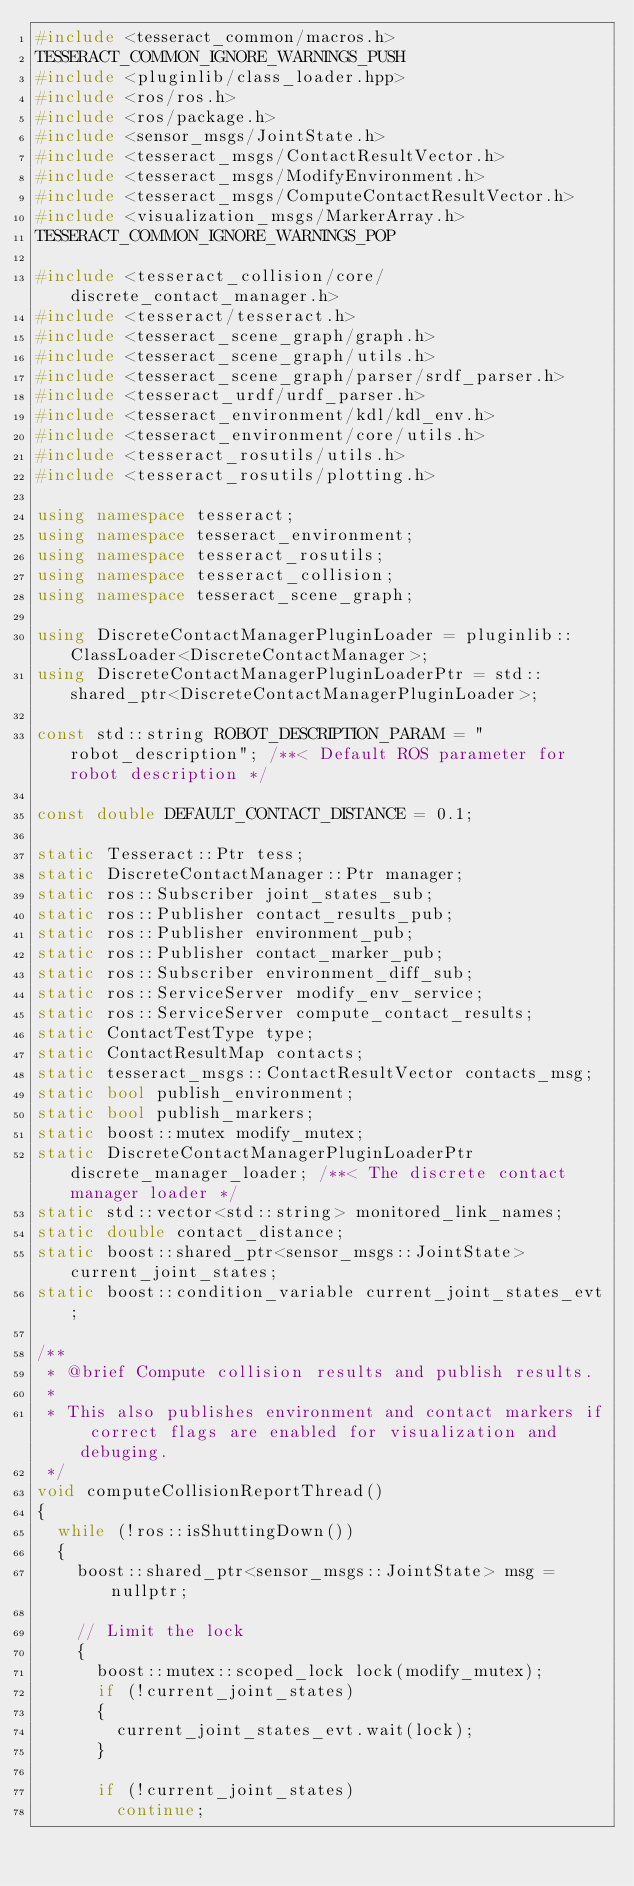<code> <loc_0><loc_0><loc_500><loc_500><_C++_>#include <tesseract_common/macros.h>
TESSERACT_COMMON_IGNORE_WARNINGS_PUSH
#include <pluginlib/class_loader.hpp>
#include <ros/ros.h>
#include <ros/package.h>
#include <sensor_msgs/JointState.h>
#include <tesseract_msgs/ContactResultVector.h>
#include <tesseract_msgs/ModifyEnvironment.h>
#include <tesseract_msgs/ComputeContactResultVector.h>
#include <visualization_msgs/MarkerArray.h>
TESSERACT_COMMON_IGNORE_WARNINGS_POP

#include <tesseract_collision/core/discrete_contact_manager.h>
#include <tesseract/tesseract.h>
#include <tesseract_scene_graph/graph.h>
#include <tesseract_scene_graph/utils.h>
#include <tesseract_scene_graph/parser/srdf_parser.h>
#include <tesseract_urdf/urdf_parser.h>
#include <tesseract_environment/kdl/kdl_env.h>
#include <tesseract_environment/core/utils.h>
#include <tesseract_rosutils/utils.h>
#include <tesseract_rosutils/plotting.h>

using namespace tesseract;
using namespace tesseract_environment;
using namespace tesseract_rosutils;
using namespace tesseract_collision;
using namespace tesseract_scene_graph;

using DiscreteContactManagerPluginLoader = pluginlib::ClassLoader<DiscreteContactManager>;
using DiscreteContactManagerPluginLoaderPtr = std::shared_ptr<DiscreteContactManagerPluginLoader>;

const std::string ROBOT_DESCRIPTION_PARAM = "robot_description"; /**< Default ROS parameter for robot description */

const double DEFAULT_CONTACT_DISTANCE = 0.1;

static Tesseract::Ptr tess;
static DiscreteContactManager::Ptr manager;
static ros::Subscriber joint_states_sub;
static ros::Publisher contact_results_pub;
static ros::Publisher environment_pub;
static ros::Publisher contact_marker_pub;
static ros::Subscriber environment_diff_sub;
static ros::ServiceServer modify_env_service;
static ros::ServiceServer compute_contact_results;
static ContactTestType type;
static ContactResultMap contacts;
static tesseract_msgs::ContactResultVector contacts_msg;
static bool publish_environment;
static bool publish_markers;
static boost::mutex modify_mutex;
static DiscreteContactManagerPluginLoaderPtr discrete_manager_loader; /**< The discrete contact manager loader */
static std::vector<std::string> monitored_link_names;
static double contact_distance;
static boost::shared_ptr<sensor_msgs::JointState> current_joint_states;
static boost::condition_variable current_joint_states_evt;

/**
 * @brief Compute collision results and publish results.
 *
 * This also publishes environment and contact markers if correct flags are enabled for visualization and debuging.
 */
void computeCollisionReportThread()
{
  while (!ros::isShuttingDown())
  {
    boost::shared_ptr<sensor_msgs::JointState> msg = nullptr;

    // Limit the lock
    {
      boost::mutex::scoped_lock lock(modify_mutex);
      if (!current_joint_states)
      {
        current_joint_states_evt.wait(lock);
      }

      if (!current_joint_states)
        continue;
</code> 